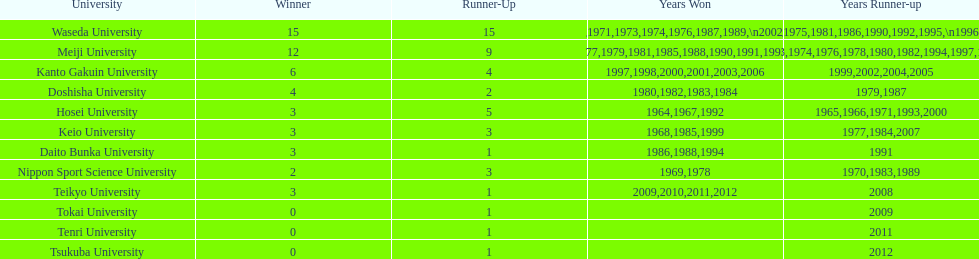I'm looking to parse the entire table for insights. Could you assist me with that? {'header': ['University', 'Winner', 'Runner-Up', 'Years Won', 'Years Runner-up'], 'rows': [['Waseda University', '15', '15', '1965,1966,1968,1970,1971,1973,1974,1976,1987,1989,\\n2002,2004,2005,2007,2008', '1964,1967,1969,1972,1975,1981,1986,1990,1992,1995,\\n1996,2001,2003,2006,2010'], ['Meiji University', '12', '9', '1972,1975,1977,1979,1981,1985,1988,1990,1991,1993,\\n1995,1996', '1973,1974,1976,1978,1980,1982,1994,1997,1998'], ['Kanto Gakuin University', '6', '4', '1997,1998,2000,2001,2003,2006', '1999,2002,2004,2005'], ['Doshisha University', '4', '2', '1980,1982,1983,1984', '1979,1987'], ['Hosei University', '3', '5', '1964,1967,1992', '1965,1966,1971,1993,2000'], ['Keio University', '3', '3', '1968,1985,1999', '1977,1984,2007'], ['Daito Bunka University', '3', '1', '1986,1988,1994', '1991'], ['Nippon Sport Science University', '2', '3', '1969,1978', '1970,1983,1989'], ['Teikyo University', '3', '1', '2009,2010,2011,2012', '2008'], ['Tokai University', '0', '1', '', '2009'], ['Tenri University', '0', '1', '', '2011'], ['Tsukuba University', '0', '1', '', '2012']]} Which universities accumulated a total exceeding 12 triumphs? Waseda University. 